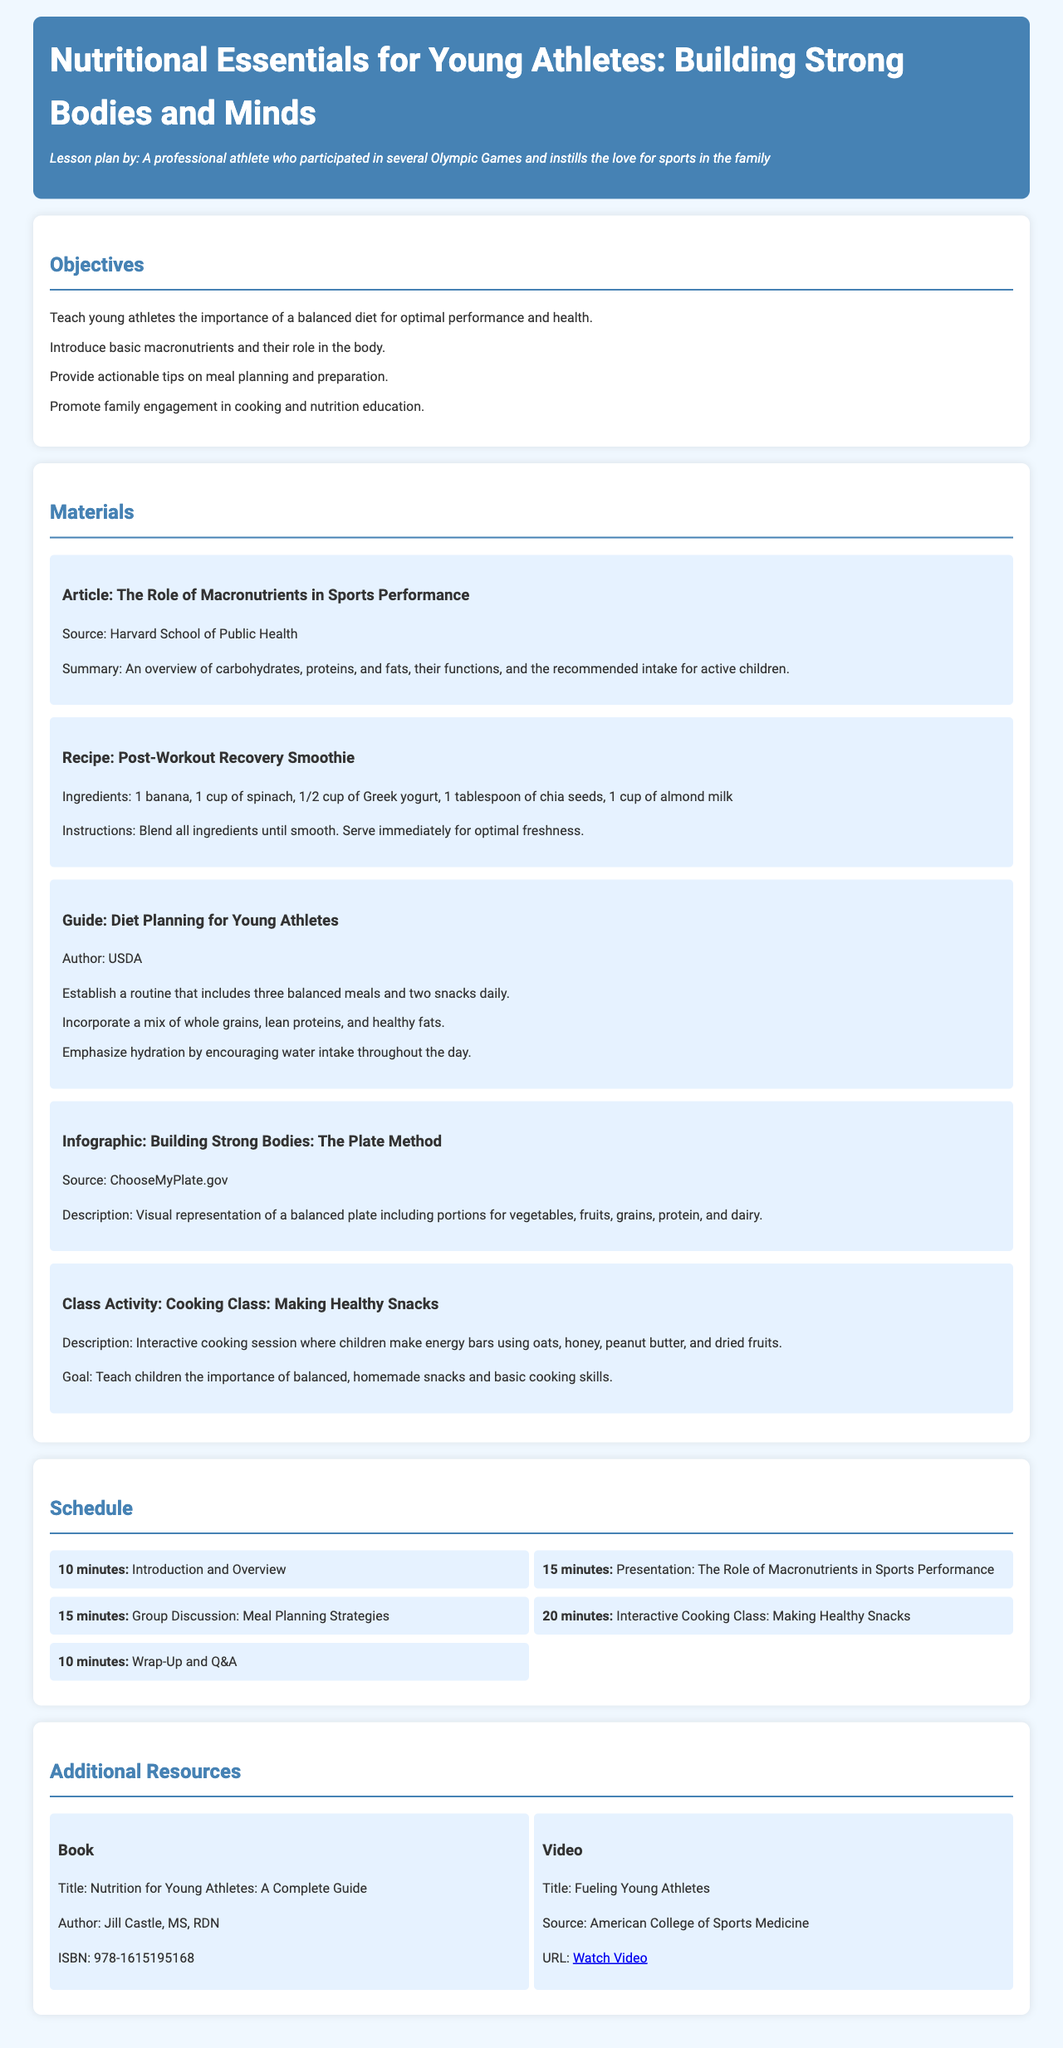What is the primary focus of the lesson plan? The primary focus of the lesson plan is to educate young athletes about the importance of nutrition and diet for their performance and health.
Answer: Nutrition and diet Who is the author of the article on macronutrients? The document states that the article on macronutrients is sourced from the Harvard School of Public Health.
Answer: Harvard School of Public Health What is included in the recipe for the smoothie? The recipe for the smoothie includes 1 banana, 1 cup of spinach, 1/2 cup of Greek yogurt, 1 tablespoon of chia seeds, and 1 cup of almond milk.
Answer: 1 banana, 1 cup of spinach, 1/2 cup of Greek yogurt, 1 tablespoon of chia seeds, 1 cup of almond milk How many balanced meals should young athletes have daily according to the diet planning guide? According to the guide, young athletes should establish a routine that includes three balanced meals daily.
Answer: Three What is the duration of the Wrap-Up and Q&A session? The duration of the Wrap-Up and Q&A session is 10 minutes as stated in the schedule section of the document.
Answer: 10 minutes What type of class activity is featured in the lesson plan? The lesson plan features an interactive cooking class where children make energy bars.
Answer: Cooking class Who is the author of the additional resource book on nutrition? The author of the additional resource book "Nutrition for Young Athletes: A Complete Guide" is Jill Castle, MS, RDN.
Answer: Jill Castle, MS, RDN What is the title of the video resource provided? The title of the video resource provided is "Fueling Young Athletes."
Answer: Fueling Young Athletes 